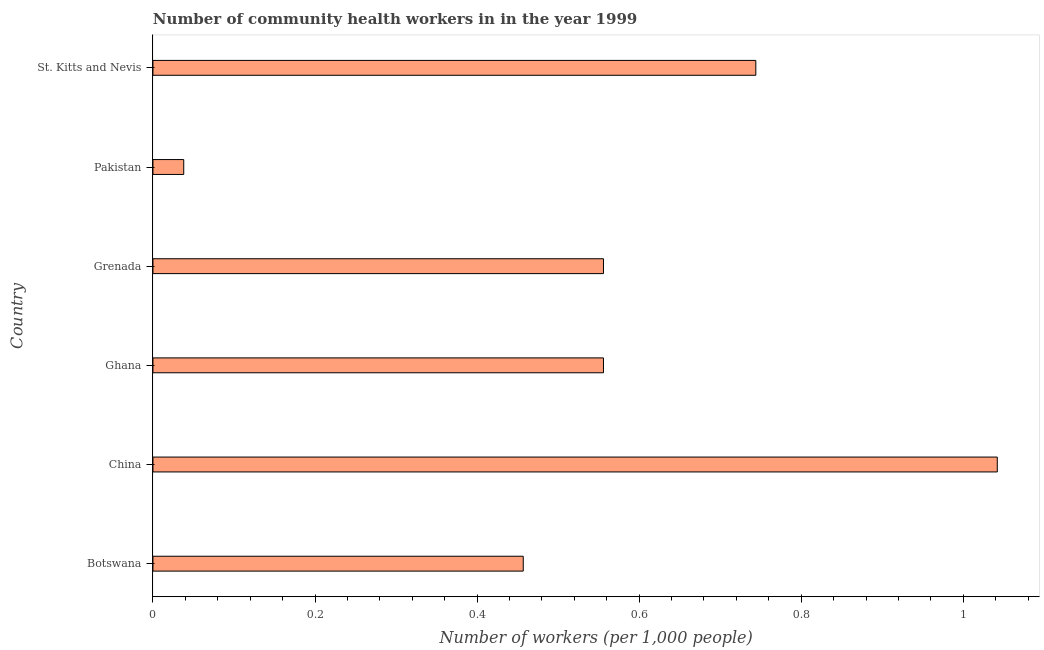Does the graph contain grids?
Offer a terse response. No. What is the title of the graph?
Give a very brief answer. Number of community health workers in in the year 1999. What is the label or title of the X-axis?
Provide a succinct answer. Number of workers (per 1,0 people). What is the label or title of the Y-axis?
Offer a very short reply. Country. What is the number of community health workers in Botswana?
Keep it short and to the point. 0.46. Across all countries, what is the maximum number of community health workers?
Provide a succinct answer. 1.04. Across all countries, what is the minimum number of community health workers?
Offer a terse response. 0.04. In which country was the number of community health workers maximum?
Offer a very short reply. China. In which country was the number of community health workers minimum?
Offer a terse response. Pakistan. What is the sum of the number of community health workers?
Provide a short and direct response. 3.39. What is the difference between the number of community health workers in China and St. Kitts and Nevis?
Your answer should be compact. 0.3. What is the average number of community health workers per country?
Provide a short and direct response. 0.57. What is the median number of community health workers?
Offer a terse response. 0.56. What is the ratio of the number of community health workers in Botswana to that in St. Kitts and Nevis?
Your response must be concise. 0.61. Is the number of community health workers in China less than that in Ghana?
Offer a very short reply. No. What is the difference between the highest and the second highest number of community health workers?
Keep it short and to the point. 0.3. What is the difference between the highest and the lowest number of community health workers?
Ensure brevity in your answer.  1. In how many countries, is the number of community health workers greater than the average number of community health workers taken over all countries?
Make the answer very short. 2. How many countries are there in the graph?
Your answer should be compact. 6. What is the difference between two consecutive major ticks on the X-axis?
Make the answer very short. 0.2. What is the Number of workers (per 1,000 people) in Botswana?
Make the answer very short. 0.46. What is the Number of workers (per 1,000 people) of China?
Your answer should be compact. 1.04. What is the Number of workers (per 1,000 people) in Ghana?
Your answer should be very brief. 0.56. What is the Number of workers (per 1,000 people) of Grenada?
Your answer should be compact. 0.56. What is the Number of workers (per 1,000 people) of Pakistan?
Ensure brevity in your answer.  0.04. What is the Number of workers (per 1,000 people) in St. Kitts and Nevis?
Your response must be concise. 0.74. What is the difference between the Number of workers (per 1,000 people) in Botswana and China?
Offer a very short reply. -0.58. What is the difference between the Number of workers (per 1,000 people) in Botswana and Ghana?
Offer a terse response. -0.1. What is the difference between the Number of workers (per 1,000 people) in Botswana and Grenada?
Give a very brief answer. -0.1. What is the difference between the Number of workers (per 1,000 people) in Botswana and Pakistan?
Offer a terse response. 0.42. What is the difference between the Number of workers (per 1,000 people) in Botswana and St. Kitts and Nevis?
Ensure brevity in your answer.  -0.29. What is the difference between the Number of workers (per 1,000 people) in China and Ghana?
Ensure brevity in your answer.  0.49. What is the difference between the Number of workers (per 1,000 people) in China and Grenada?
Give a very brief answer. 0.49. What is the difference between the Number of workers (per 1,000 people) in China and St. Kitts and Nevis?
Provide a short and direct response. 0.3. What is the difference between the Number of workers (per 1,000 people) in Ghana and Grenada?
Your answer should be very brief. 0. What is the difference between the Number of workers (per 1,000 people) in Ghana and Pakistan?
Offer a very short reply. 0.52. What is the difference between the Number of workers (per 1,000 people) in Ghana and St. Kitts and Nevis?
Offer a terse response. -0.19. What is the difference between the Number of workers (per 1,000 people) in Grenada and Pakistan?
Your answer should be compact. 0.52. What is the difference between the Number of workers (per 1,000 people) in Grenada and St. Kitts and Nevis?
Offer a very short reply. -0.19. What is the difference between the Number of workers (per 1,000 people) in Pakistan and St. Kitts and Nevis?
Your answer should be compact. -0.71. What is the ratio of the Number of workers (per 1,000 people) in Botswana to that in China?
Your response must be concise. 0.44. What is the ratio of the Number of workers (per 1,000 people) in Botswana to that in Ghana?
Give a very brief answer. 0.82. What is the ratio of the Number of workers (per 1,000 people) in Botswana to that in Grenada?
Make the answer very short. 0.82. What is the ratio of the Number of workers (per 1,000 people) in Botswana to that in Pakistan?
Your response must be concise. 12.03. What is the ratio of the Number of workers (per 1,000 people) in Botswana to that in St. Kitts and Nevis?
Your response must be concise. 0.61. What is the ratio of the Number of workers (per 1,000 people) in China to that in Ghana?
Your answer should be compact. 1.87. What is the ratio of the Number of workers (per 1,000 people) in China to that in Grenada?
Offer a very short reply. 1.87. What is the ratio of the Number of workers (per 1,000 people) in China to that in Pakistan?
Your answer should be very brief. 27.42. What is the ratio of the Number of workers (per 1,000 people) in China to that in St. Kitts and Nevis?
Offer a very short reply. 1.4. What is the ratio of the Number of workers (per 1,000 people) in Ghana to that in Pakistan?
Make the answer very short. 14.63. What is the ratio of the Number of workers (per 1,000 people) in Ghana to that in St. Kitts and Nevis?
Offer a terse response. 0.75. What is the ratio of the Number of workers (per 1,000 people) in Grenada to that in Pakistan?
Ensure brevity in your answer.  14.63. What is the ratio of the Number of workers (per 1,000 people) in Grenada to that in St. Kitts and Nevis?
Give a very brief answer. 0.75. What is the ratio of the Number of workers (per 1,000 people) in Pakistan to that in St. Kitts and Nevis?
Provide a succinct answer. 0.05. 